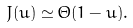Convert formula to latex. <formula><loc_0><loc_0><loc_500><loc_500>J ( u ) \simeq \Theta ( 1 - u ) .</formula> 